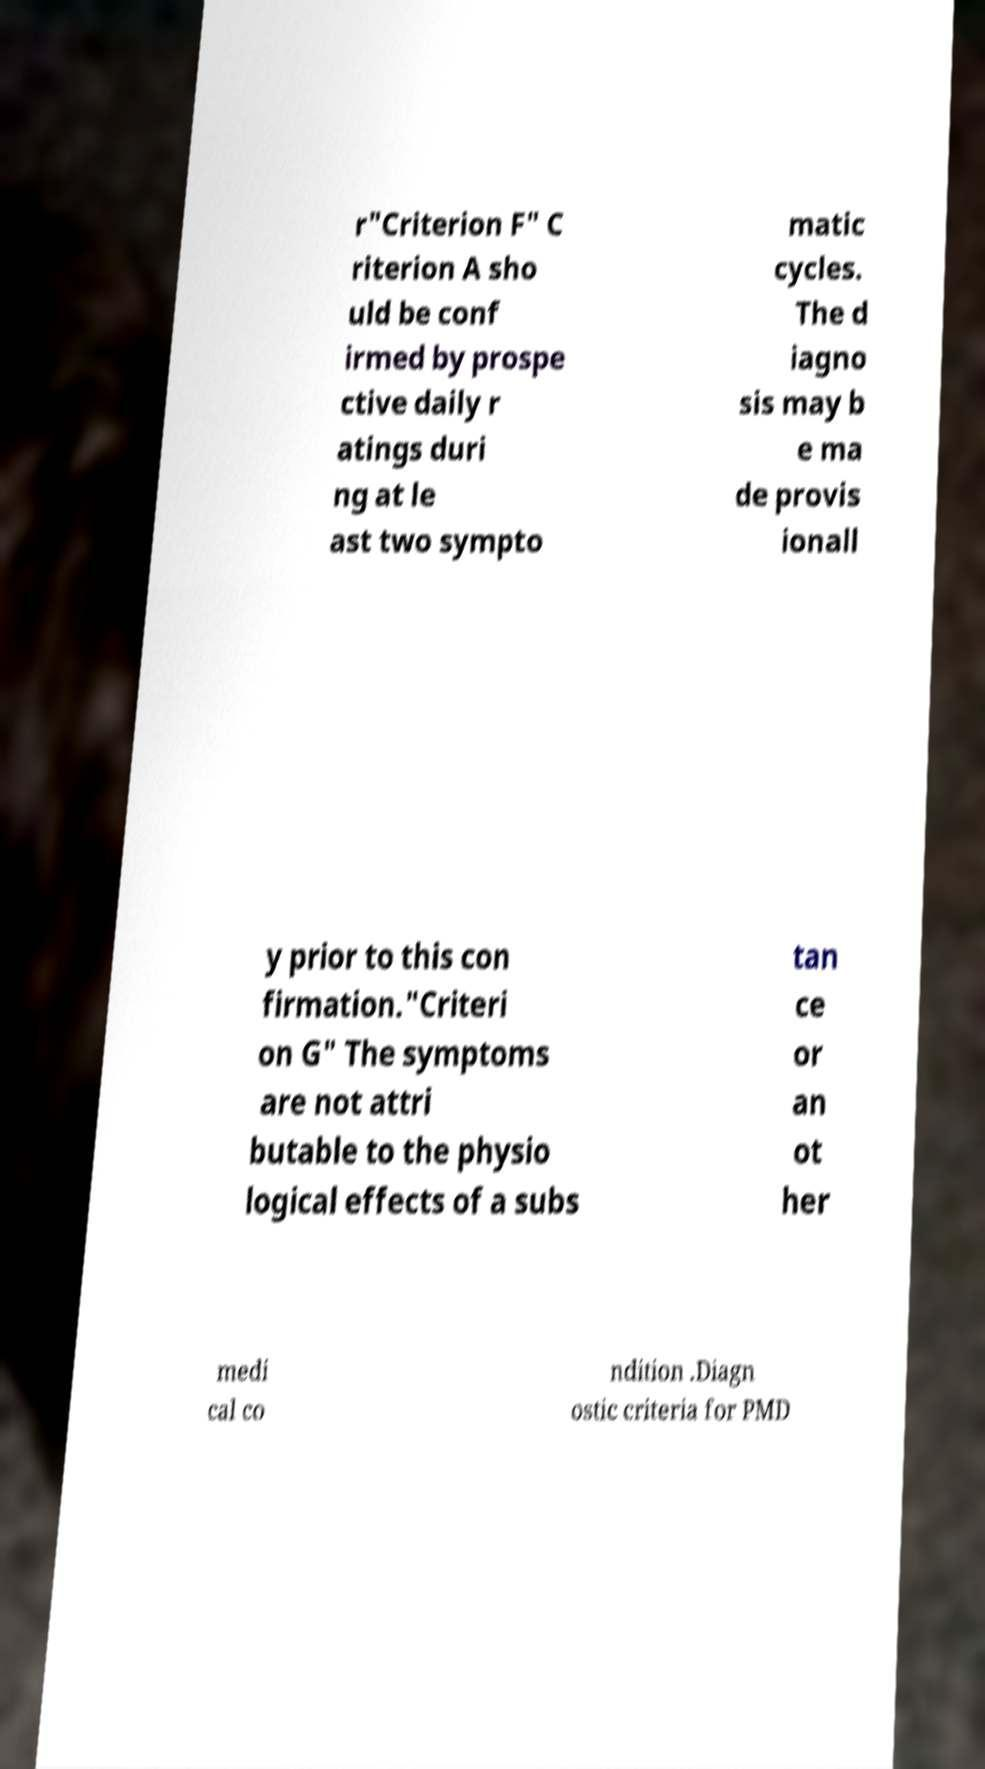For documentation purposes, I need the text within this image transcribed. Could you provide that? r"Criterion F" C riterion A sho uld be conf irmed by prospe ctive daily r atings duri ng at le ast two sympto matic cycles. The d iagno sis may b e ma de provis ionall y prior to this con firmation."Criteri on G" The symptoms are not attri butable to the physio logical effects of a subs tan ce or an ot her medi cal co ndition .Diagn ostic criteria for PMD 